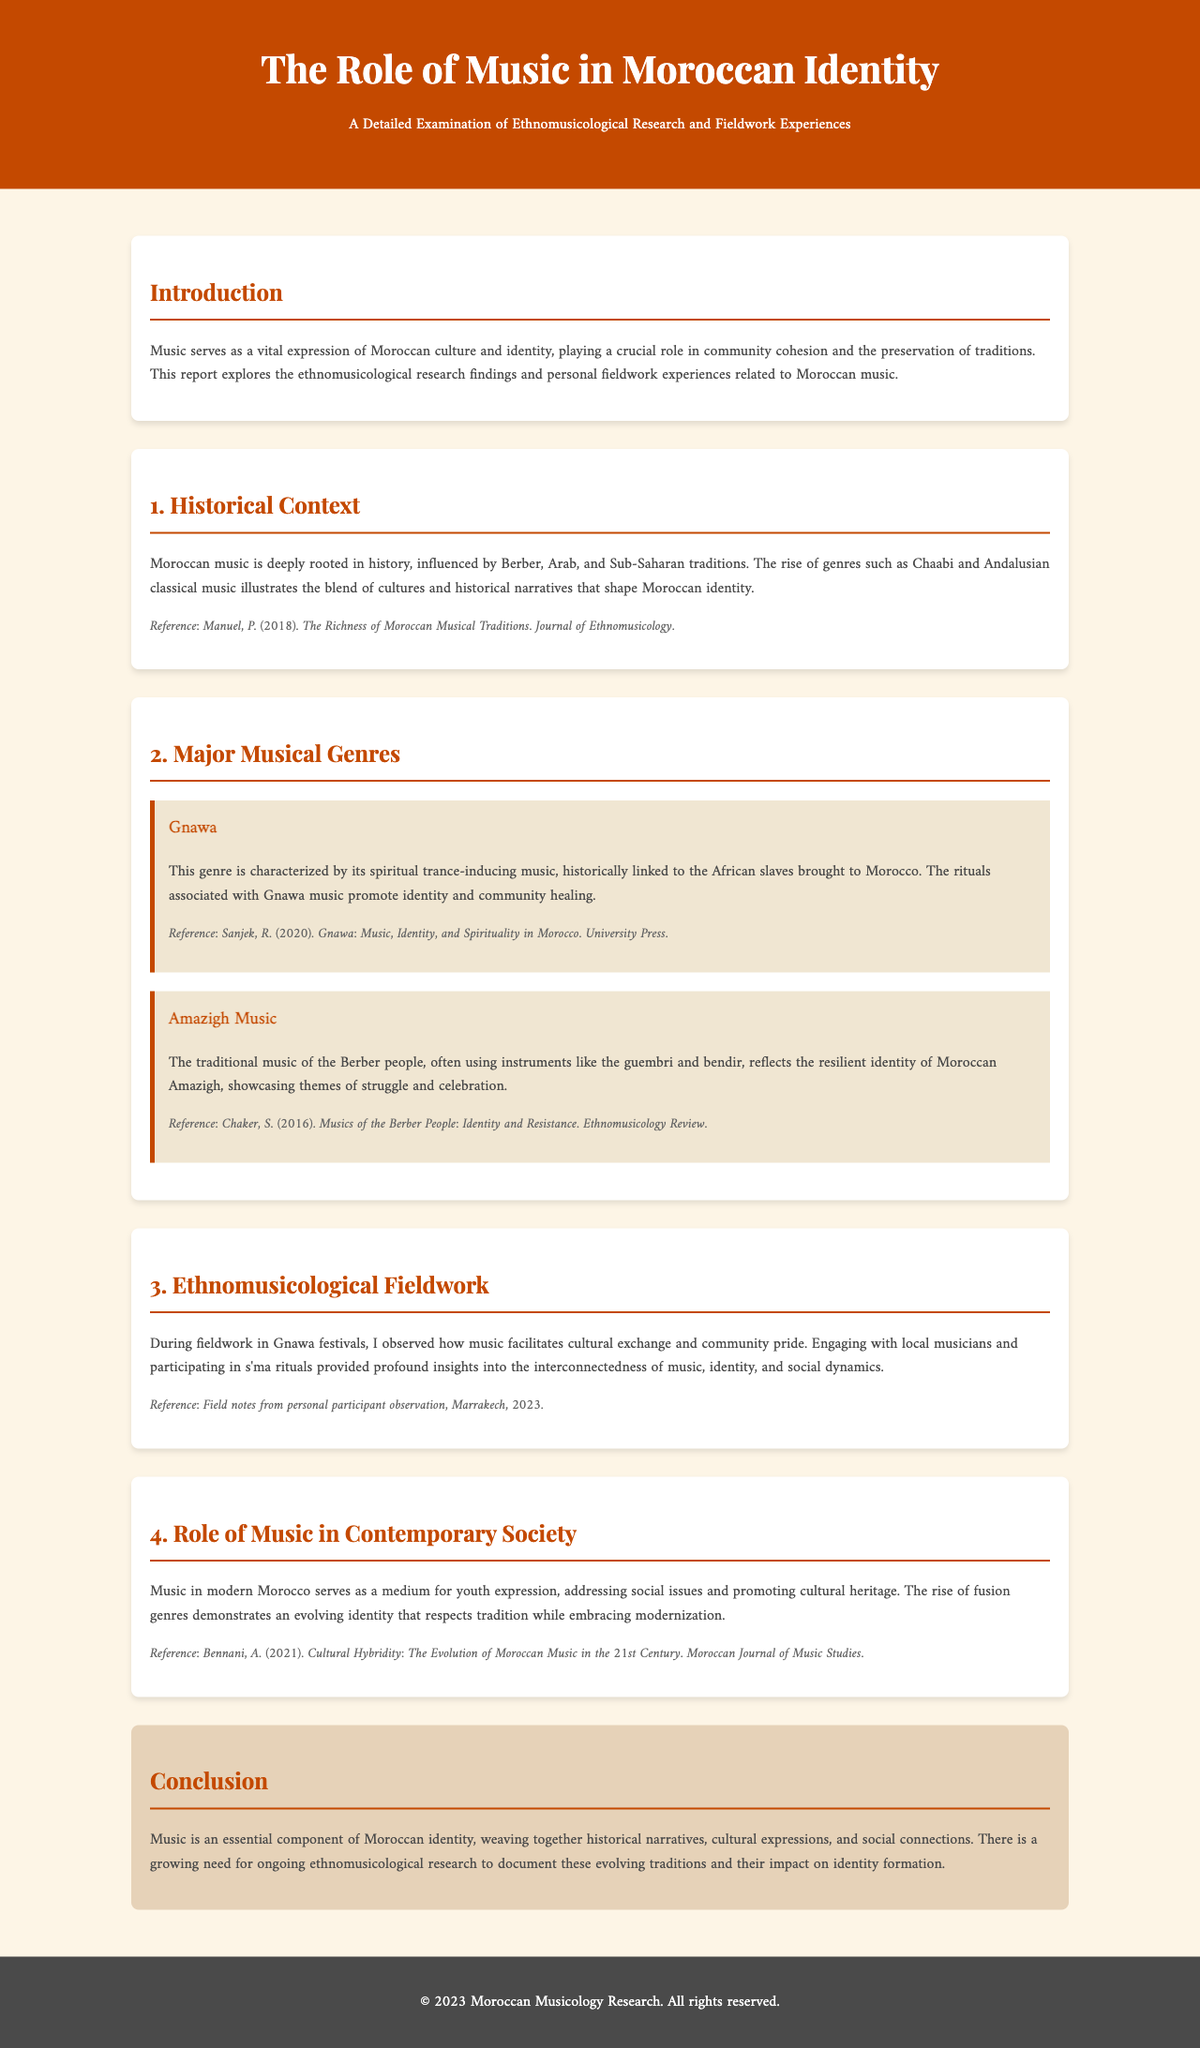What is the title of the report? The title of the report is mentioned in the header as "The Role of Music in Moroccan Identity."
Answer: The Role of Music in Moroccan Identity Who is the author of the report? The report does not directly mention an author's name, but it is associated with "Moroccan Musicology Research" in the footer.
Answer: Moroccan Musicology Research What musical genre is characterized by trance-inducing music? The genre specifically linked to this characteristic is described within the document.
Answer: Gnawa What instruments are commonly used in Amazigh music? The document lists specific instruments related to this genre within its description.
Answer: guembri and bendir What year did the fieldwork in Marrakech occur? The date is specified in the section discussing fieldwork experiences, indicating when the observations took place.
Answer: 2023 What does contemporary Moroccan music address? The document mentions a specific aspect related to the content of contemporary music in Morocco.
Answer: social issues How does the conclusion summarize the role of music? The conclusion provides a succinct overview of music's significance in Moroccan identity and its components.
Answer: essential component What is the main focus of ethnomusicological research mentioned in the report? The report identifies a central theme for ongoing research, particularly regarding traditions and identity.
Answer: evolving traditions and their impact on identity formation 